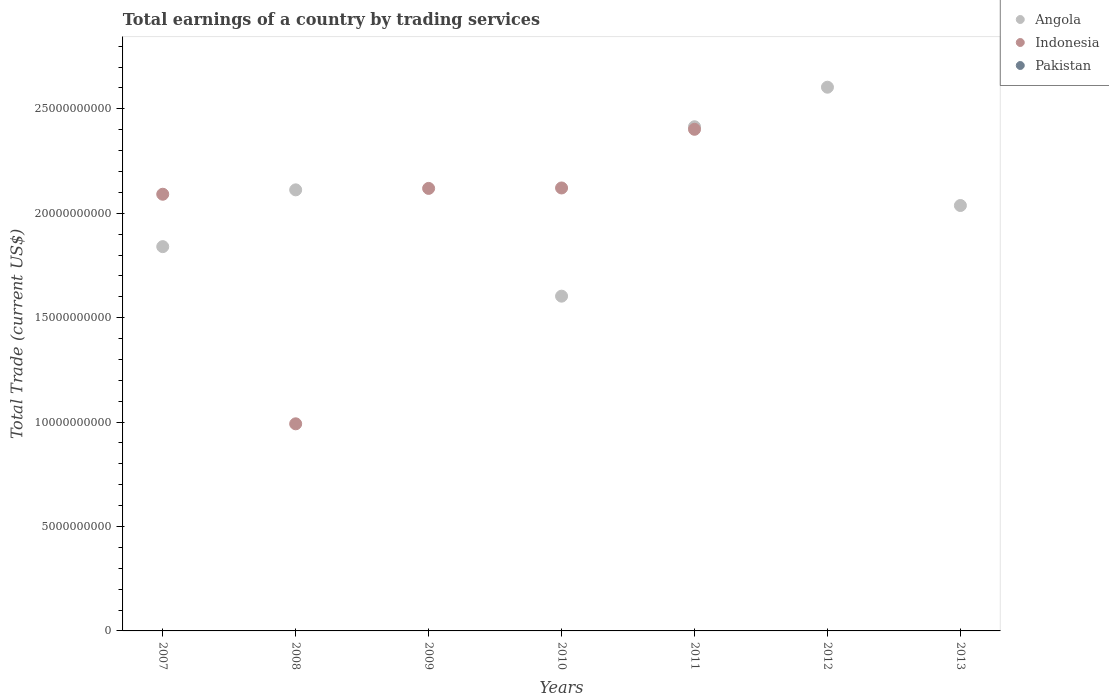Is the number of dotlines equal to the number of legend labels?
Your answer should be very brief. No. What is the total earnings in Angola in 2007?
Keep it short and to the point. 1.84e+1. Across all years, what is the maximum total earnings in Indonesia?
Your response must be concise. 2.40e+1. Across all years, what is the minimum total earnings in Angola?
Your response must be concise. 0. What is the total total earnings in Indonesia in the graph?
Make the answer very short. 9.73e+1. What is the difference between the total earnings in Angola in 2008 and that in 2010?
Your answer should be very brief. 5.09e+09. What is the difference between the total earnings in Pakistan in 2009 and the total earnings in Angola in 2012?
Provide a succinct answer. -2.60e+1. In the year 2011, what is the difference between the total earnings in Angola and total earnings in Indonesia?
Provide a succinct answer. 1.22e+08. In how many years, is the total earnings in Angola greater than 8000000000 US$?
Ensure brevity in your answer.  6. What is the ratio of the total earnings in Angola in 2012 to that in 2013?
Your answer should be very brief. 1.28. Is the difference between the total earnings in Angola in 2007 and 2010 greater than the difference between the total earnings in Indonesia in 2007 and 2010?
Your answer should be very brief. Yes. What is the difference between the highest and the second highest total earnings in Angola?
Give a very brief answer. 1.89e+09. What is the difference between the highest and the lowest total earnings in Angola?
Make the answer very short. 2.60e+1. In how many years, is the total earnings in Indonesia greater than the average total earnings in Indonesia taken over all years?
Ensure brevity in your answer.  4. How many dotlines are there?
Your response must be concise. 2. How many years are there in the graph?
Ensure brevity in your answer.  7. Are the values on the major ticks of Y-axis written in scientific E-notation?
Provide a succinct answer. No. Does the graph contain any zero values?
Make the answer very short. Yes. Where does the legend appear in the graph?
Give a very brief answer. Top right. How are the legend labels stacked?
Ensure brevity in your answer.  Vertical. What is the title of the graph?
Ensure brevity in your answer.  Total earnings of a country by trading services. Does "Kosovo" appear as one of the legend labels in the graph?
Ensure brevity in your answer.  No. What is the label or title of the X-axis?
Make the answer very short. Years. What is the label or title of the Y-axis?
Ensure brevity in your answer.  Total Trade (current US$). What is the Total Trade (current US$) in Angola in 2007?
Give a very brief answer. 1.84e+1. What is the Total Trade (current US$) in Indonesia in 2007?
Keep it short and to the point. 2.09e+1. What is the Total Trade (current US$) in Angola in 2008?
Ensure brevity in your answer.  2.11e+1. What is the Total Trade (current US$) in Indonesia in 2008?
Offer a very short reply. 9.92e+09. What is the Total Trade (current US$) of Pakistan in 2008?
Your answer should be very brief. 0. What is the Total Trade (current US$) of Angola in 2009?
Provide a succinct answer. 0. What is the Total Trade (current US$) in Indonesia in 2009?
Ensure brevity in your answer.  2.12e+1. What is the Total Trade (current US$) of Pakistan in 2009?
Offer a very short reply. 0. What is the Total Trade (current US$) in Angola in 2010?
Your response must be concise. 1.60e+1. What is the Total Trade (current US$) in Indonesia in 2010?
Ensure brevity in your answer.  2.12e+1. What is the Total Trade (current US$) of Angola in 2011?
Give a very brief answer. 2.41e+1. What is the Total Trade (current US$) in Indonesia in 2011?
Provide a short and direct response. 2.40e+1. What is the Total Trade (current US$) of Angola in 2012?
Offer a very short reply. 2.60e+1. What is the Total Trade (current US$) in Angola in 2013?
Offer a terse response. 2.04e+1. What is the Total Trade (current US$) in Indonesia in 2013?
Ensure brevity in your answer.  0. What is the Total Trade (current US$) in Pakistan in 2013?
Keep it short and to the point. 0. Across all years, what is the maximum Total Trade (current US$) in Angola?
Offer a very short reply. 2.60e+1. Across all years, what is the maximum Total Trade (current US$) in Indonesia?
Your answer should be compact. 2.40e+1. What is the total Total Trade (current US$) in Angola in the graph?
Your answer should be compact. 1.26e+11. What is the total Total Trade (current US$) in Indonesia in the graph?
Keep it short and to the point. 9.73e+1. What is the difference between the Total Trade (current US$) of Angola in 2007 and that in 2008?
Make the answer very short. -2.72e+09. What is the difference between the Total Trade (current US$) of Indonesia in 2007 and that in 2008?
Ensure brevity in your answer.  1.10e+1. What is the difference between the Total Trade (current US$) in Indonesia in 2007 and that in 2009?
Provide a succinct answer. -2.79e+08. What is the difference between the Total Trade (current US$) of Angola in 2007 and that in 2010?
Keep it short and to the point. 2.37e+09. What is the difference between the Total Trade (current US$) of Indonesia in 2007 and that in 2010?
Offer a very short reply. -3.00e+08. What is the difference between the Total Trade (current US$) of Angola in 2007 and that in 2011?
Your response must be concise. -5.74e+09. What is the difference between the Total Trade (current US$) in Indonesia in 2007 and that in 2011?
Your response must be concise. -3.11e+09. What is the difference between the Total Trade (current US$) of Angola in 2007 and that in 2012?
Your answer should be very brief. -7.63e+09. What is the difference between the Total Trade (current US$) of Angola in 2007 and that in 2013?
Provide a short and direct response. -1.97e+09. What is the difference between the Total Trade (current US$) of Indonesia in 2008 and that in 2009?
Your answer should be very brief. -1.13e+1. What is the difference between the Total Trade (current US$) in Angola in 2008 and that in 2010?
Make the answer very short. 5.09e+09. What is the difference between the Total Trade (current US$) of Indonesia in 2008 and that in 2010?
Your answer should be compact. -1.13e+1. What is the difference between the Total Trade (current US$) in Angola in 2008 and that in 2011?
Your answer should be compact. -3.02e+09. What is the difference between the Total Trade (current US$) of Indonesia in 2008 and that in 2011?
Your answer should be very brief. -1.41e+1. What is the difference between the Total Trade (current US$) of Angola in 2008 and that in 2012?
Your response must be concise. -4.92e+09. What is the difference between the Total Trade (current US$) of Angola in 2008 and that in 2013?
Provide a succinct answer. 7.50e+08. What is the difference between the Total Trade (current US$) of Indonesia in 2009 and that in 2010?
Your response must be concise. -2.11e+07. What is the difference between the Total Trade (current US$) of Indonesia in 2009 and that in 2011?
Give a very brief answer. -2.83e+09. What is the difference between the Total Trade (current US$) of Angola in 2010 and that in 2011?
Make the answer very short. -8.11e+09. What is the difference between the Total Trade (current US$) in Indonesia in 2010 and that in 2011?
Provide a short and direct response. -2.81e+09. What is the difference between the Total Trade (current US$) of Angola in 2010 and that in 2012?
Ensure brevity in your answer.  -1.00e+1. What is the difference between the Total Trade (current US$) of Angola in 2010 and that in 2013?
Make the answer very short. -4.34e+09. What is the difference between the Total Trade (current US$) in Angola in 2011 and that in 2012?
Make the answer very short. -1.89e+09. What is the difference between the Total Trade (current US$) of Angola in 2011 and that in 2013?
Provide a succinct answer. 3.77e+09. What is the difference between the Total Trade (current US$) in Angola in 2012 and that in 2013?
Keep it short and to the point. 5.67e+09. What is the difference between the Total Trade (current US$) in Angola in 2007 and the Total Trade (current US$) in Indonesia in 2008?
Provide a succinct answer. 8.48e+09. What is the difference between the Total Trade (current US$) of Angola in 2007 and the Total Trade (current US$) of Indonesia in 2009?
Your answer should be compact. -2.79e+09. What is the difference between the Total Trade (current US$) in Angola in 2007 and the Total Trade (current US$) in Indonesia in 2010?
Ensure brevity in your answer.  -2.81e+09. What is the difference between the Total Trade (current US$) in Angola in 2007 and the Total Trade (current US$) in Indonesia in 2011?
Offer a very short reply. -5.62e+09. What is the difference between the Total Trade (current US$) of Angola in 2008 and the Total Trade (current US$) of Indonesia in 2009?
Make the answer very short. -6.92e+07. What is the difference between the Total Trade (current US$) in Angola in 2008 and the Total Trade (current US$) in Indonesia in 2010?
Your answer should be compact. -9.03e+07. What is the difference between the Total Trade (current US$) of Angola in 2008 and the Total Trade (current US$) of Indonesia in 2011?
Offer a very short reply. -2.90e+09. What is the difference between the Total Trade (current US$) of Angola in 2010 and the Total Trade (current US$) of Indonesia in 2011?
Give a very brief answer. -7.99e+09. What is the average Total Trade (current US$) of Angola per year?
Provide a succinct answer. 1.80e+1. What is the average Total Trade (current US$) of Indonesia per year?
Keep it short and to the point. 1.39e+1. What is the average Total Trade (current US$) of Pakistan per year?
Your response must be concise. 0. In the year 2007, what is the difference between the Total Trade (current US$) in Angola and Total Trade (current US$) in Indonesia?
Keep it short and to the point. -2.51e+09. In the year 2008, what is the difference between the Total Trade (current US$) in Angola and Total Trade (current US$) in Indonesia?
Your response must be concise. 1.12e+1. In the year 2010, what is the difference between the Total Trade (current US$) in Angola and Total Trade (current US$) in Indonesia?
Make the answer very short. -5.18e+09. In the year 2011, what is the difference between the Total Trade (current US$) of Angola and Total Trade (current US$) of Indonesia?
Offer a very short reply. 1.22e+08. What is the ratio of the Total Trade (current US$) of Angola in 2007 to that in 2008?
Keep it short and to the point. 0.87. What is the ratio of the Total Trade (current US$) of Indonesia in 2007 to that in 2008?
Make the answer very short. 2.11. What is the ratio of the Total Trade (current US$) in Indonesia in 2007 to that in 2009?
Your answer should be compact. 0.99. What is the ratio of the Total Trade (current US$) of Angola in 2007 to that in 2010?
Your response must be concise. 1.15. What is the ratio of the Total Trade (current US$) in Indonesia in 2007 to that in 2010?
Offer a terse response. 0.99. What is the ratio of the Total Trade (current US$) of Angola in 2007 to that in 2011?
Ensure brevity in your answer.  0.76. What is the ratio of the Total Trade (current US$) of Indonesia in 2007 to that in 2011?
Keep it short and to the point. 0.87. What is the ratio of the Total Trade (current US$) in Angola in 2007 to that in 2012?
Provide a succinct answer. 0.71. What is the ratio of the Total Trade (current US$) of Angola in 2007 to that in 2013?
Make the answer very short. 0.9. What is the ratio of the Total Trade (current US$) of Indonesia in 2008 to that in 2009?
Give a very brief answer. 0.47. What is the ratio of the Total Trade (current US$) in Angola in 2008 to that in 2010?
Offer a very short reply. 1.32. What is the ratio of the Total Trade (current US$) of Indonesia in 2008 to that in 2010?
Provide a succinct answer. 0.47. What is the ratio of the Total Trade (current US$) of Angola in 2008 to that in 2011?
Provide a short and direct response. 0.87. What is the ratio of the Total Trade (current US$) of Indonesia in 2008 to that in 2011?
Provide a succinct answer. 0.41. What is the ratio of the Total Trade (current US$) in Angola in 2008 to that in 2012?
Your response must be concise. 0.81. What is the ratio of the Total Trade (current US$) of Angola in 2008 to that in 2013?
Make the answer very short. 1.04. What is the ratio of the Total Trade (current US$) in Indonesia in 2009 to that in 2011?
Your answer should be very brief. 0.88. What is the ratio of the Total Trade (current US$) of Angola in 2010 to that in 2011?
Keep it short and to the point. 0.66. What is the ratio of the Total Trade (current US$) in Indonesia in 2010 to that in 2011?
Keep it short and to the point. 0.88. What is the ratio of the Total Trade (current US$) in Angola in 2010 to that in 2012?
Keep it short and to the point. 0.62. What is the ratio of the Total Trade (current US$) in Angola in 2010 to that in 2013?
Ensure brevity in your answer.  0.79. What is the ratio of the Total Trade (current US$) of Angola in 2011 to that in 2012?
Make the answer very short. 0.93. What is the ratio of the Total Trade (current US$) of Angola in 2011 to that in 2013?
Your answer should be very brief. 1.19. What is the ratio of the Total Trade (current US$) in Angola in 2012 to that in 2013?
Your answer should be very brief. 1.28. What is the difference between the highest and the second highest Total Trade (current US$) in Angola?
Your response must be concise. 1.89e+09. What is the difference between the highest and the second highest Total Trade (current US$) of Indonesia?
Offer a terse response. 2.81e+09. What is the difference between the highest and the lowest Total Trade (current US$) of Angola?
Your answer should be very brief. 2.60e+1. What is the difference between the highest and the lowest Total Trade (current US$) in Indonesia?
Your answer should be compact. 2.40e+1. 